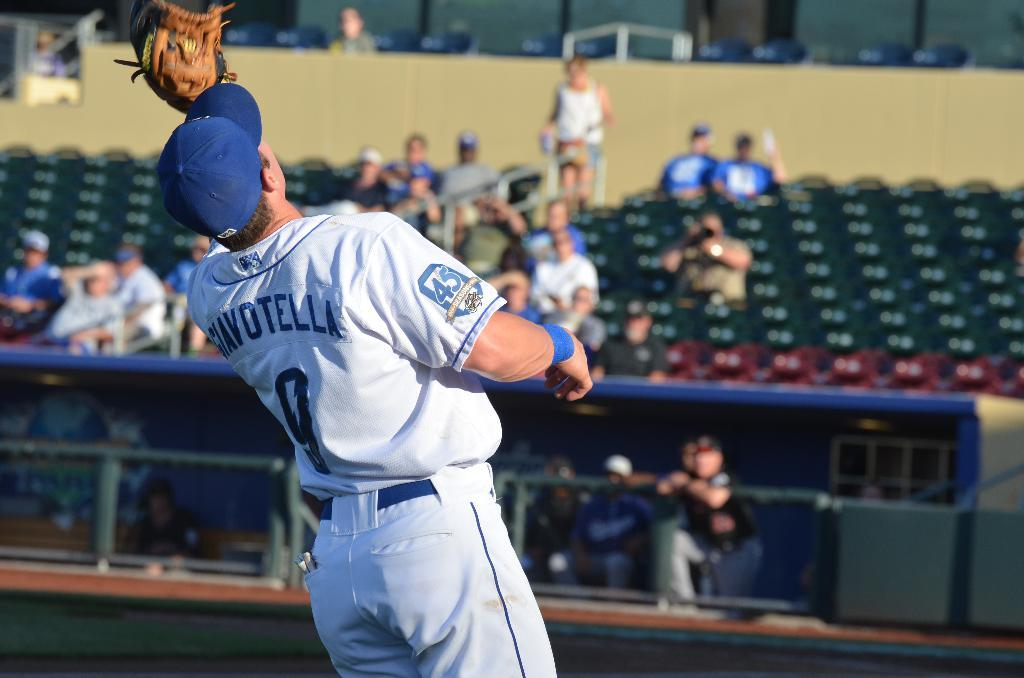<image>
Relay a brief, clear account of the picture shown. A baseball player named Giavotella reaches up for a ball. 